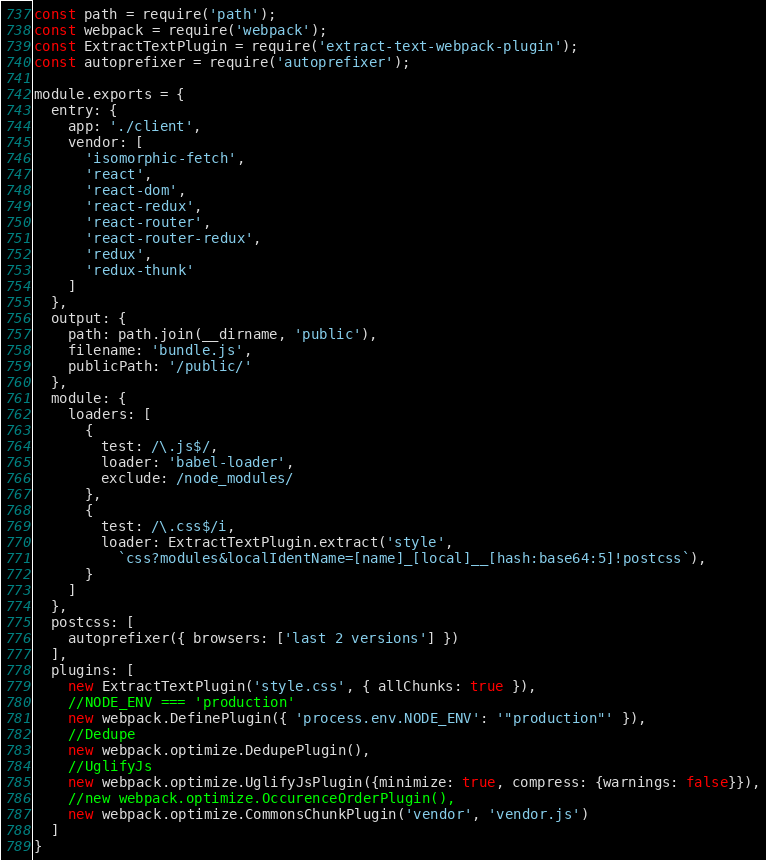<code> <loc_0><loc_0><loc_500><loc_500><_JavaScript_>const path = require('path');
const webpack = require('webpack');
const ExtractTextPlugin = require('extract-text-webpack-plugin');
const autoprefixer = require('autoprefixer');

module.exports = {
  entry: {
    app: './client',
    vendor: [
      'isomorphic-fetch',
      'react',
      'react-dom',
      'react-redux',
      'react-router',
      'react-router-redux',
      'redux',
      'redux-thunk'
    ]
  },
  output: {
    path: path.join(__dirname, 'public'),
    filename: 'bundle.js',
    publicPath: '/public/'
  },
  module: {
    loaders: [
      { 
        test: /\.js$/,
        loader: 'babel-loader',
        exclude: /node_modules/
      },
      {
        test: /\.css$/i,
        loader: ExtractTextPlugin.extract('style',
          `css?modules&localIdentName=[name]_[local]__[hash:base64:5]!postcss`),
      }
    ]
  },
  postcss: [ 
    autoprefixer({ browsers: ['last 2 versions'] }) 
  ],
  plugins: [
    new ExtractTextPlugin('style.css', { allChunks: true }),
    //NODE_ENV === 'production'
    new webpack.DefinePlugin({ 'process.env.NODE_ENV': '"production"' }),
    //Dedupe
    new webpack.optimize.DedupePlugin(),
    //UglifyJs
    new webpack.optimize.UglifyJsPlugin({minimize: true, compress: {warnings: false}}),
    //new webpack.optimize.OccurenceOrderPlugin(),
    new webpack.optimize.CommonsChunkPlugin('vendor', 'vendor.js')
  ]
}
</code> 